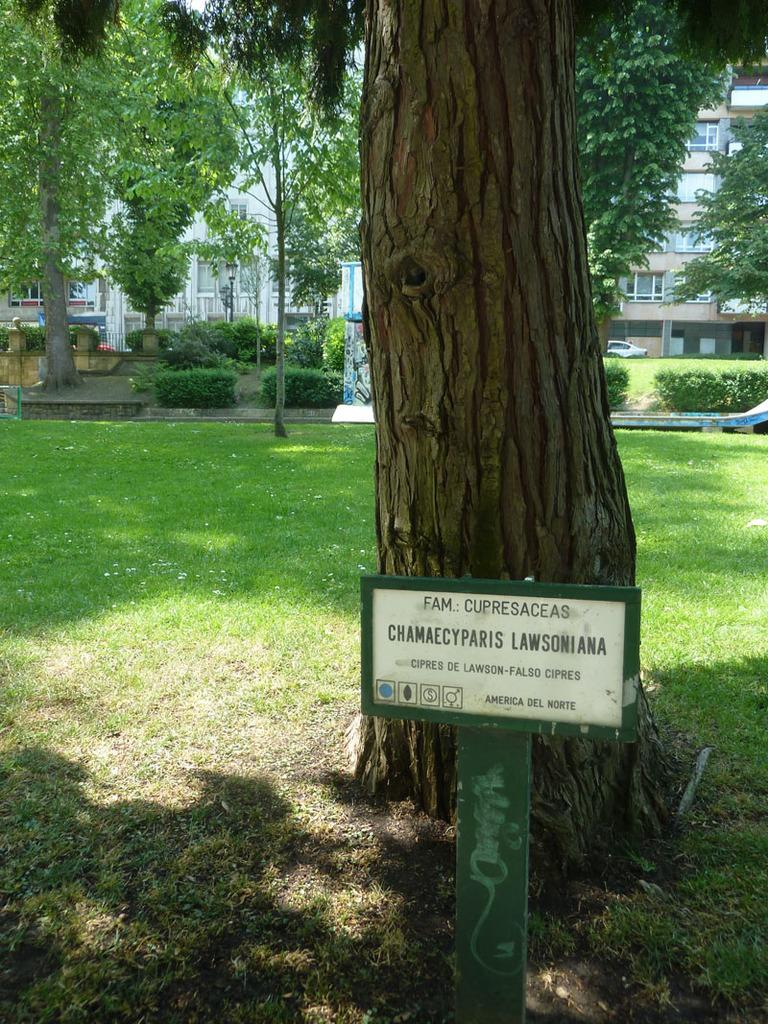What is the main object in the image? There is a board in the image. What type of environment is depicted in the image? The image shows grassland and trees. Are there any man-made structures visible in the image? Yes, there are light poles and buildings in the image. Is there any indication of human presence in the image? Yes, there is a car parked in the image. How does the seat blow in the wind in the image? There is no seat present in the image, so it cannot blow in the wind. 